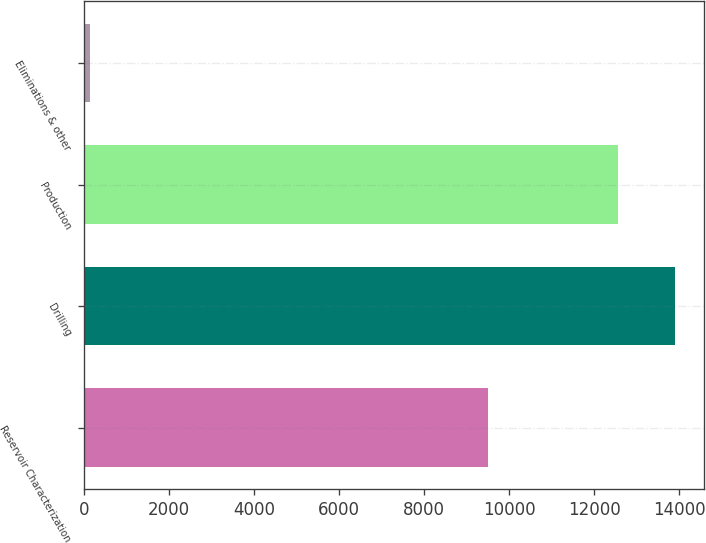Convert chart. <chart><loc_0><loc_0><loc_500><loc_500><bar_chart><fcel>Reservoir Characterization<fcel>Drilling<fcel>Production<fcel>Eliminations & other<nl><fcel>9501<fcel>13890.6<fcel>12548<fcel>137<nl></chart> 